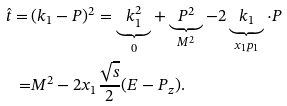<formula> <loc_0><loc_0><loc_500><loc_500>\hat { t } = \, & ( k _ { 1 } - P ) ^ { 2 } = \underbrace { k _ { 1 } ^ { 2 } } _ { 0 } + \underbrace { P ^ { 2 } } _ { M ^ { 2 } } - 2 \underbrace { k _ { 1 } } _ { x _ { 1 } p _ { 1 } } \cdot P \\ = & M ^ { 2 } - 2 x _ { 1 } \frac { \sqrt { s } } { 2 } ( E - P _ { z } ) .</formula> 